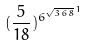Convert formula to latex. <formula><loc_0><loc_0><loc_500><loc_500>( \frac { 5 } { 1 8 } ) ^ { { 6 ^ { \sqrt { 3 6 8 } } } ^ { 1 } }</formula> 